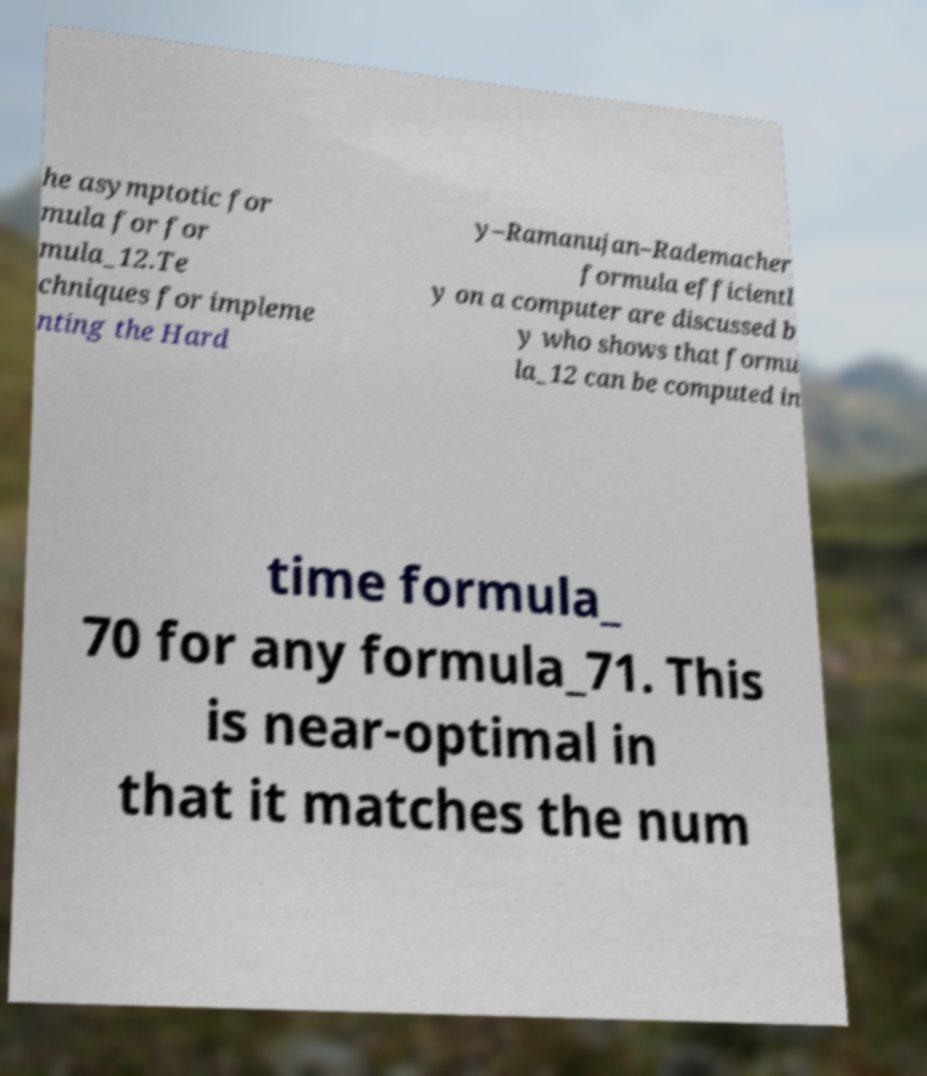Can you read and provide the text displayed in the image?This photo seems to have some interesting text. Can you extract and type it out for me? he asymptotic for mula for for mula_12.Te chniques for impleme nting the Hard y–Ramanujan–Rademacher formula efficientl y on a computer are discussed b y who shows that formu la_12 can be computed in time formula_ 70 for any formula_71. This is near-optimal in that it matches the num 